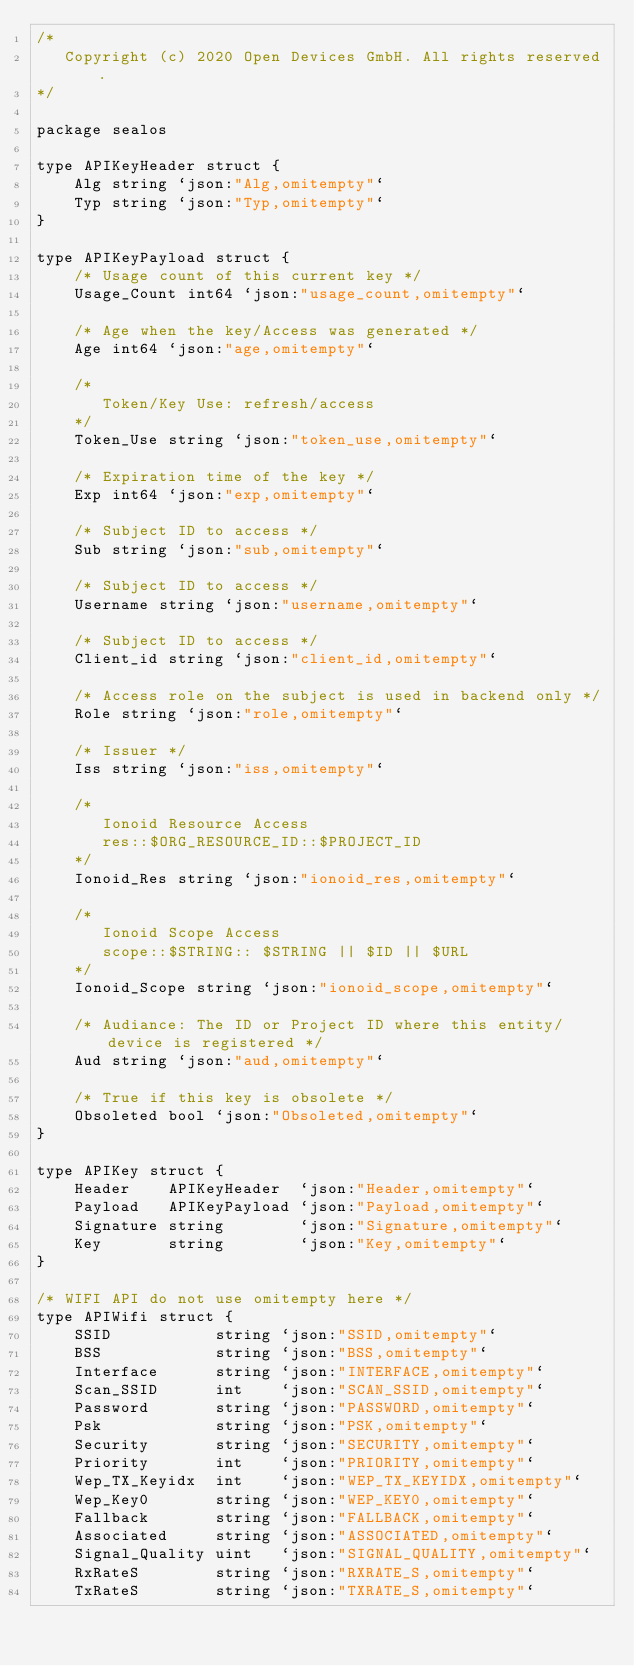<code> <loc_0><loc_0><loc_500><loc_500><_Go_>/*
   Copyright (c) 2020 Open Devices GmbH. All rights reserved.
*/

package sealos

type APIKeyHeader struct {
	Alg string `json:"Alg,omitempty"`
	Typ string `json:"Typ,omitempty"`
}

type APIKeyPayload struct {
	/* Usage count of this current key */
	Usage_Count int64 `json:"usage_count,omitempty"`

	/* Age when the key/Access was generated */
	Age int64 `json:"age,omitempty"`

	/*
	   Token/Key Use: refresh/access
	*/
	Token_Use string `json:"token_use,omitempty"`

	/* Expiration time of the key */
	Exp int64 `json:"exp,omitempty"`

	/* Subject ID to access */
	Sub string `json:"sub,omitempty"`

	/* Subject ID to access */
	Username string `json:"username,omitempty"`

	/* Subject ID to access */
	Client_id string `json:"client_id,omitempty"`

	/* Access role on the subject is used in backend only */
	Role string `json:"role,omitempty"`

	/* Issuer */
	Iss string `json:"iss,omitempty"`

	/*
	   Ionoid Resource Access
	   res::$ORG_RESOURCE_ID::$PROJECT_ID
	*/
	Ionoid_Res string `json:"ionoid_res,omitempty"`

	/*
	   Ionoid Scope Access
	   scope::$STRING:: $STRING || $ID || $URL
	*/
	Ionoid_Scope string `json:"ionoid_scope,omitempty"`

	/* Audiance: The ID or Project ID where this entity/device is registered */
	Aud string `json:"aud,omitempty"`

	/* True if this key is obsolete */
	Obsoleted bool `json:"Obsoleted,omitempty"`
}

type APIKey struct {
	Header    APIKeyHeader  `json:"Header,omitempty"`
	Payload   APIKeyPayload `json:"Payload,omitempty"`
	Signature string        `json:"Signature,omitempty"`
	Key       string        `json:"Key,omitempty"`
}

/* WIFI API do not use omitempty here */
type APIWifi struct {
	SSID           string `json:"SSID,omitempty"`
	BSS            string `json:"BSS,omitempty"`
	Interface      string `json:"INTERFACE,omitempty"`
	Scan_SSID      int    `json:"SCAN_SSID,omitempty"`
	Password       string `json:"PASSWORD,omitempty"`
	Psk            string `json:"PSK,omitempty"`
	Security       string `json:"SECURITY,omitempty"`
	Priority       int    `json:"PRIORITY,omitempty"`
	Wep_TX_Keyidx  int    `json:"WEP_TX_KEYIDX,omitempty"`
	Wep_Key0       string `json:"WEP_KEY0,omitempty"`
	Fallback       string `json:"FALLBACK,omitempty"`
	Associated     string `json:"ASSOCIATED,omitempty"`
	Signal_Quality uint   `json:"SIGNAL_QUALITY,omitempty"`
	RxRateS        string `json:"RXRATE_S,omitempty"`
	TxRateS        string `json:"TXRATE_S,omitempty"`</code> 